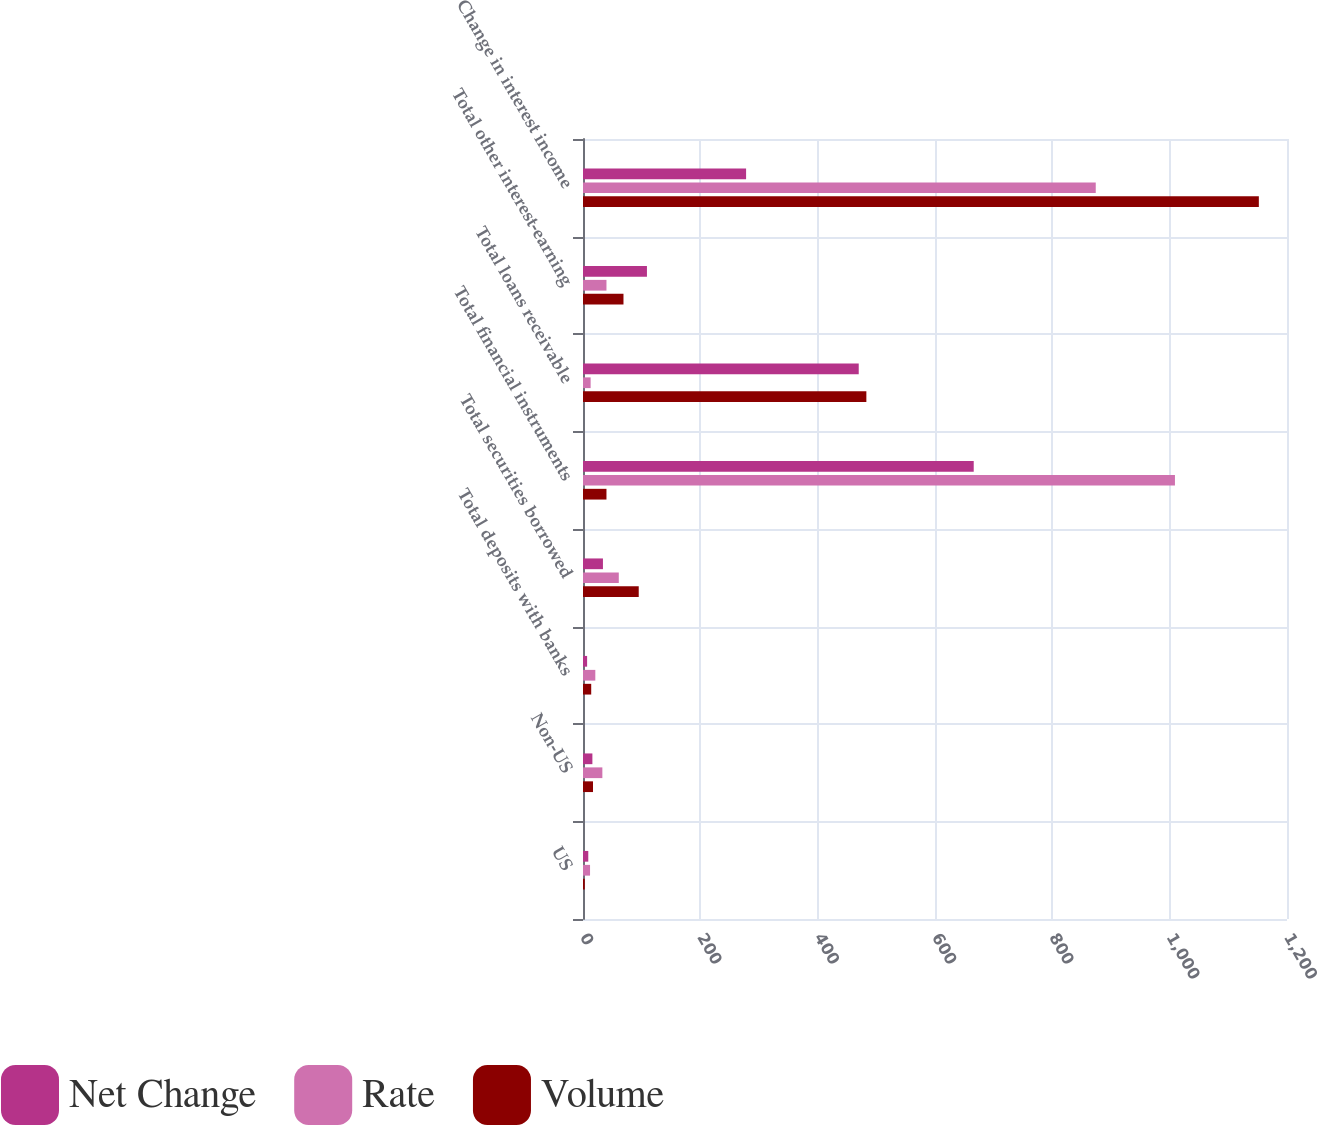<chart> <loc_0><loc_0><loc_500><loc_500><stacked_bar_chart><ecel><fcel>US<fcel>Non-US<fcel>Total deposits with banks<fcel>Total securities borrowed<fcel>Total financial instruments<fcel>Total loans receivable<fcel>Total other interest-earning<fcel>Change in interest income<nl><fcel>Net Change<fcel>9<fcel>16<fcel>7<fcel>34<fcel>666<fcel>470<fcel>109<fcel>278<nl><fcel>Rate<fcel>12<fcel>33<fcel>21<fcel>61<fcel>1009<fcel>13<fcel>40<fcel>874<nl><fcel>Volume<fcel>3<fcel>17<fcel>14<fcel>95<fcel>40<fcel>483<fcel>69<fcel>1152<nl></chart> 